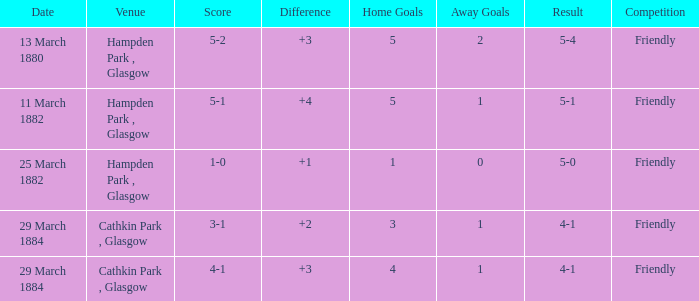Which competition had a 4-1 result, and a score of 4-1? Friendly. 